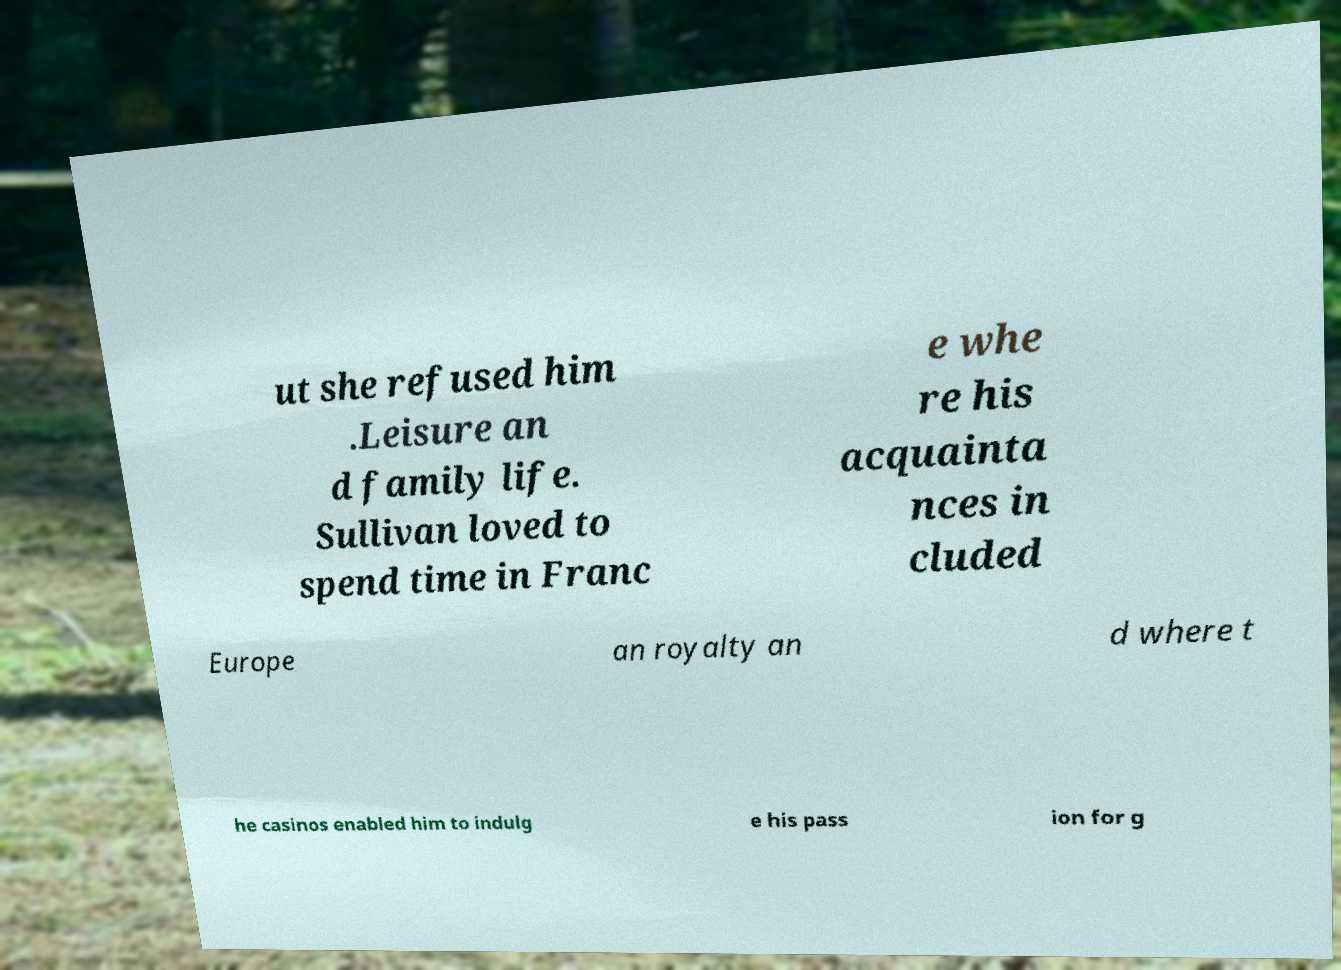Please read and relay the text visible in this image. What does it say? ut she refused him .Leisure an d family life. Sullivan loved to spend time in Franc e whe re his acquainta nces in cluded Europe an royalty an d where t he casinos enabled him to indulg e his pass ion for g 